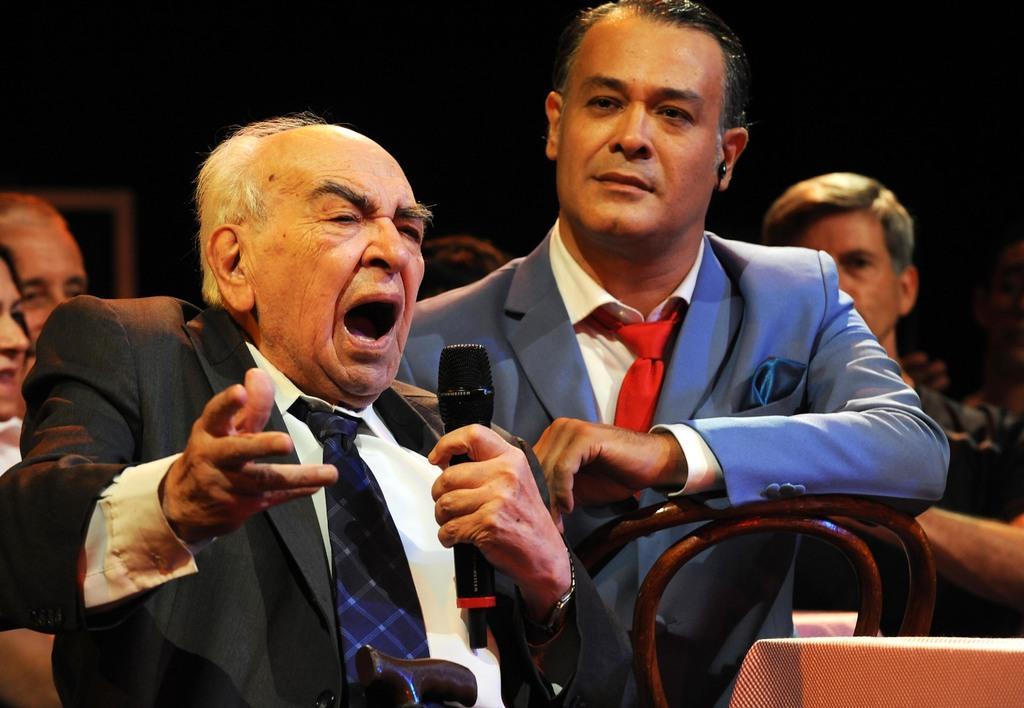How many people are in the image? There are people in the image, but the exact number is not specified. What are some of the people doing in the image? Some of the people are sitting in the image. Can you describe the man in the front of the group? The man in the front of the group is holding a microphone in his hand. What type of seat is the monkey sitting on in the image? There is no monkey present in the image, so it is not possible to answer that question. 